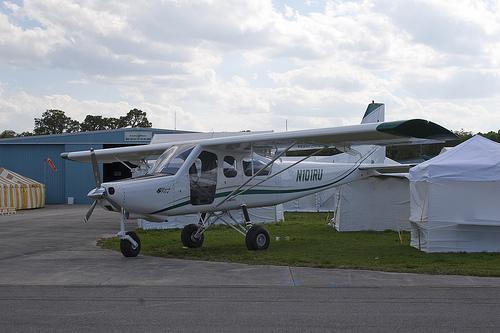How many planes are there?
Give a very brief answer. 1. 